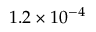Convert formula to latex. <formula><loc_0><loc_0><loc_500><loc_500>1 . 2 \times 1 0 ^ { - 4 }</formula> 